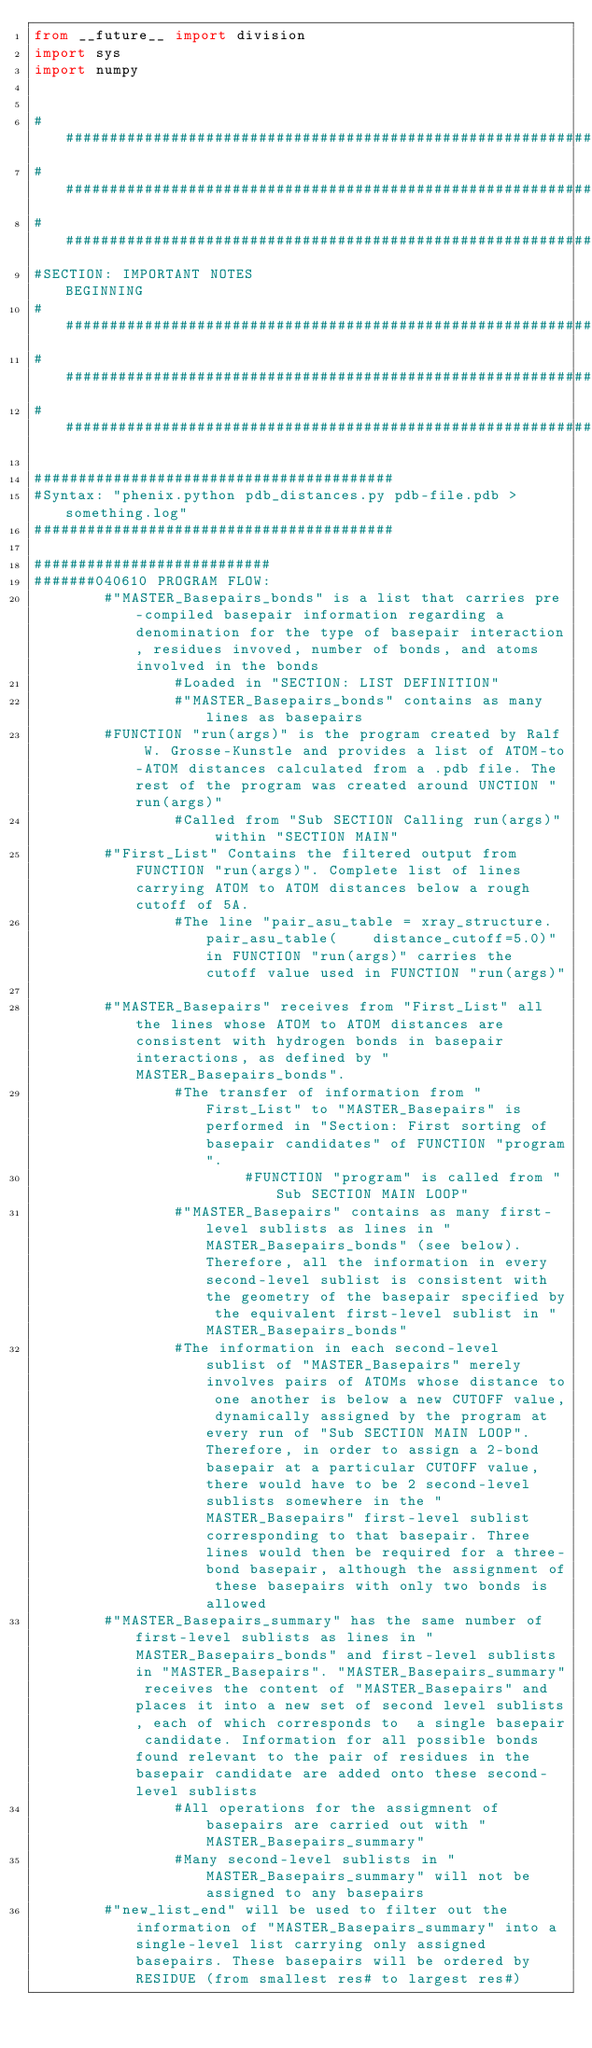Convert code to text. <code><loc_0><loc_0><loc_500><loc_500><_Python_>from __future__ import division
import sys
import numpy


##########################################################################
##########################################################################
##########################################################################
#SECTION: IMPORTANT NOTES                                 BEGINNING
##########################################################################
##########################################################################
##########################################################################

#########################################
#Syntax: "phenix.python pdb_distances.py pdb-file.pdb > something.log"
#########################################

###########################
#######040610 PROGRAM FLOW:
        #"MASTER_Basepairs_bonds" is a list that carries pre-compiled basepair information regarding a denomination for the type of basepair interaction, residues invoved, number of bonds, and atoms involved in the bonds
                #Loaded in "SECTION: LIST DEFINITION"
                #"MASTER_Basepairs_bonds" contains as many lines as basepairs
        #FUNCTION "run(args)" is the program created by Ralf W. Grosse-Kunstle and provides a list of ATOM-to-ATOM distances calculated from a .pdb file. The rest of the program was created around UNCTION "run(args)"
                #Called from "Sub SECTION Calling run(args)" within "SECTION MAIN"
        #"First_List" Contains the filtered output from FUNCTION "run(args)". Complete list of lines carrying ATOM to ATOM distances below a rough cutoff of 5A.
                #The line "pair_asu_table = xray_structure.pair_asu_table(    distance_cutoff=5.0)" in FUNCTION "run(args)" carries the cutoff value used in FUNCTION "run(args)"

        #"MASTER_Basepairs" receives from "First_List" all the lines whose ATOM to ATOM distances are consistent with hydrogen bonds in basepair interactions, as defined by "MASTER_Basepairs_bonds".
                #The transfer of information from "First_List" to "MASTER_Basepairs" is performed in "Section: First sorting of basepair candidates" of FUNCTION "program".
                        #FUNCTION "program" is called from "Sub SECTION MAIN LOOP"
                #"MASTER_Basepairs" contains as many first-level sublists as lines in "MASTER_Basepairs_bonds" (see below). Therefore, all the information in every second-level sublist is consistent with the geometry of the basepair specified by the equivalent first-level sublist in "MASTER_Basepairs_bonds"
                #The information in each second-level sublist of "MASTER_Basepairs" merely involves pairs of ATOMs whose distance to one another is below a new CUTOFF value, dynamically assigned by the program at every run of "Sub SECTION MAIN LOOP". Therefore, in order to assign a 2-bond basepair at a particular CUTOFF value, there would have to be 2 second-level sublists somewhere in the "MASTER_Basepairs" first-level sublist corresponding to that basepair. Three lines would then be required for a three-bond basepair, although the assignment of these basepairs with only two bonds is allowed
        #"MASTER_Basepairs_summary" has the same number of first-level sublists as lines in "MASTER_Basepairs_bonds" and first-level sublists in "MASTER_Basepairs". "MASTER_Basepairs_summary" receives the content of "MASTER_Basepairs" and places it into a new set of second level sublists, each of which corresponds to  a single basepair candidate. Information for all possible bonds found relevant to the pair of residues in the basepair candidate are added onto these second-level sublists
                #All operations for the assigmnent of basepairs are carried out with "MASTER_Basepairs_summary"
                #Many second-level sublists in "MASTER_Basepairs_summary" will not be assigned to any basepairs
        #"new_list_end" will be used to filter out the information of "MASTER_Basepairs_summary" into a single-level list carrying only assigned basepairs. These basepairs will be ordered by RESIDUE (from smallest res# to largest res#)</code> 